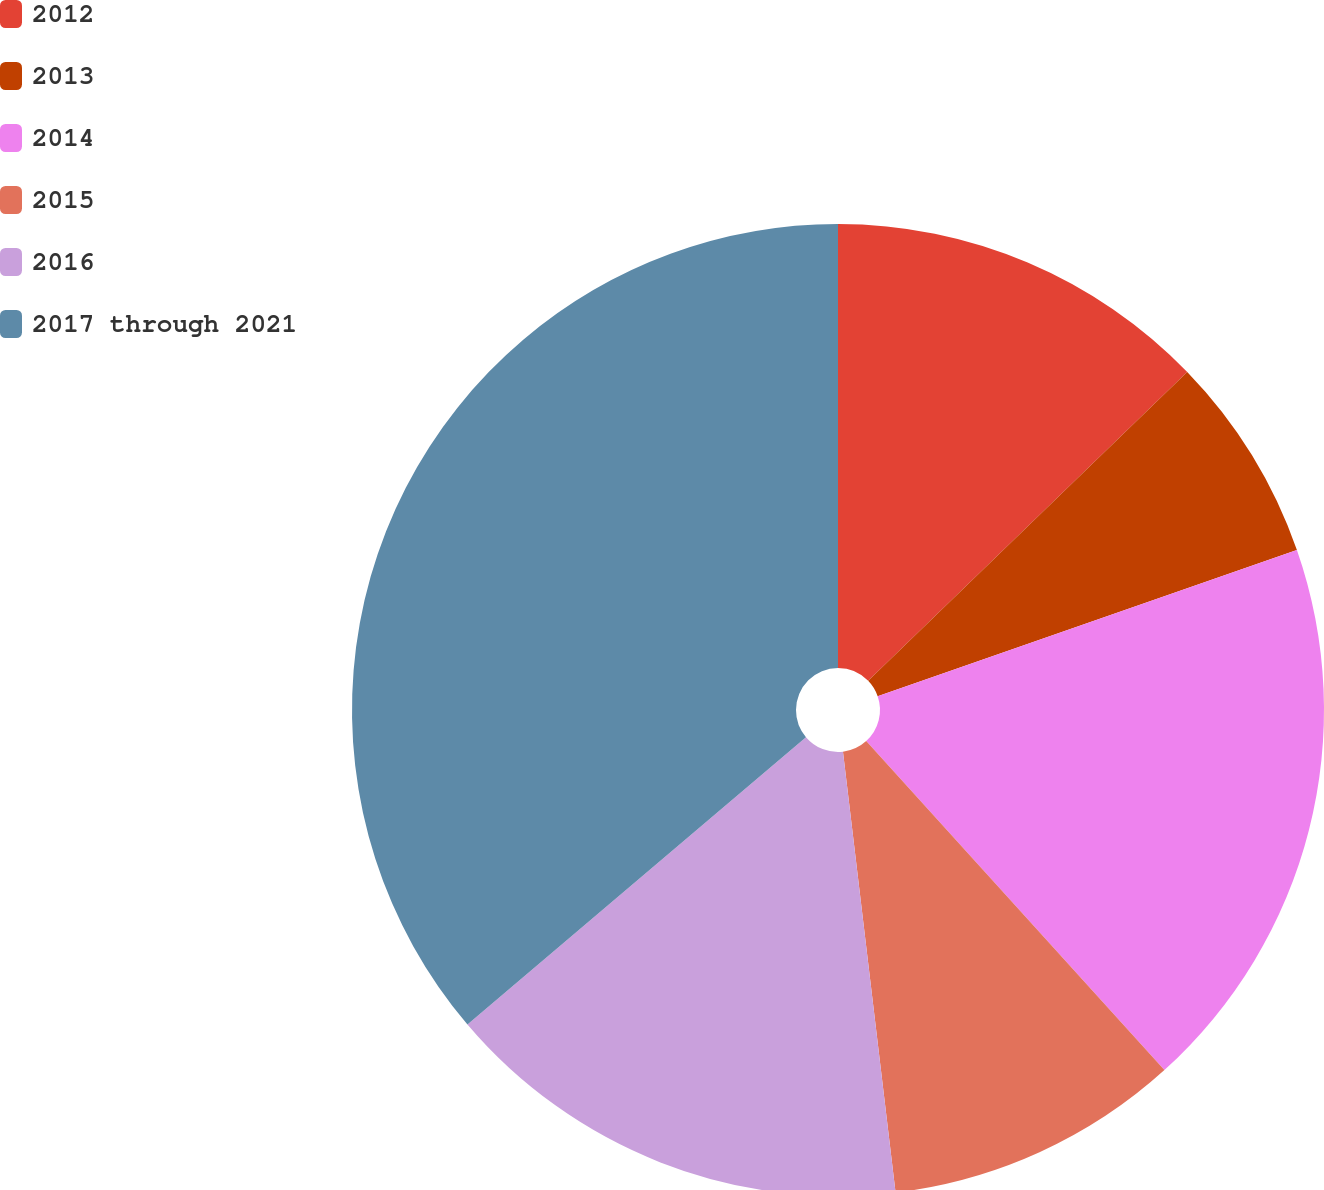Convert chart. <chart><loc_0><loc_0><loc_500><loc_500><pie_chart><fcel>2012<fcel>2013<fcel>2014<fcel>2015<fcel>2016<fcel>2017 through 2021<nl><fcel>12.76%<fcel>6.9%<fcel>18.62%<fcel>9.83%<fcel>15.69%<fcel>36.2%<nl></chart> 